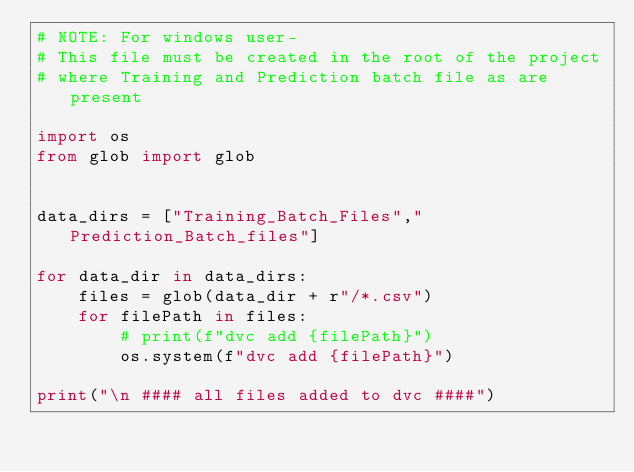<code> <loc_0><loc_0><loc_500><loc_500><_Python_># NOTE: For windows user-
# This file must be created in the root of the project 
# where Training and Prediction batch file as are present

import os
from glob import glob


data_dirs = ["Training_Batch_Files","Prediction_Batch_files"]

for data_dir in data_dirs:
    files = glob(data_dir + r"/*.csv")
    for filePath in files:
        # print(f"dvc add {filePath}")
        os.system(f"dvc add {filePath}")

print("\n #### all files added to dvc ####")
</code> 